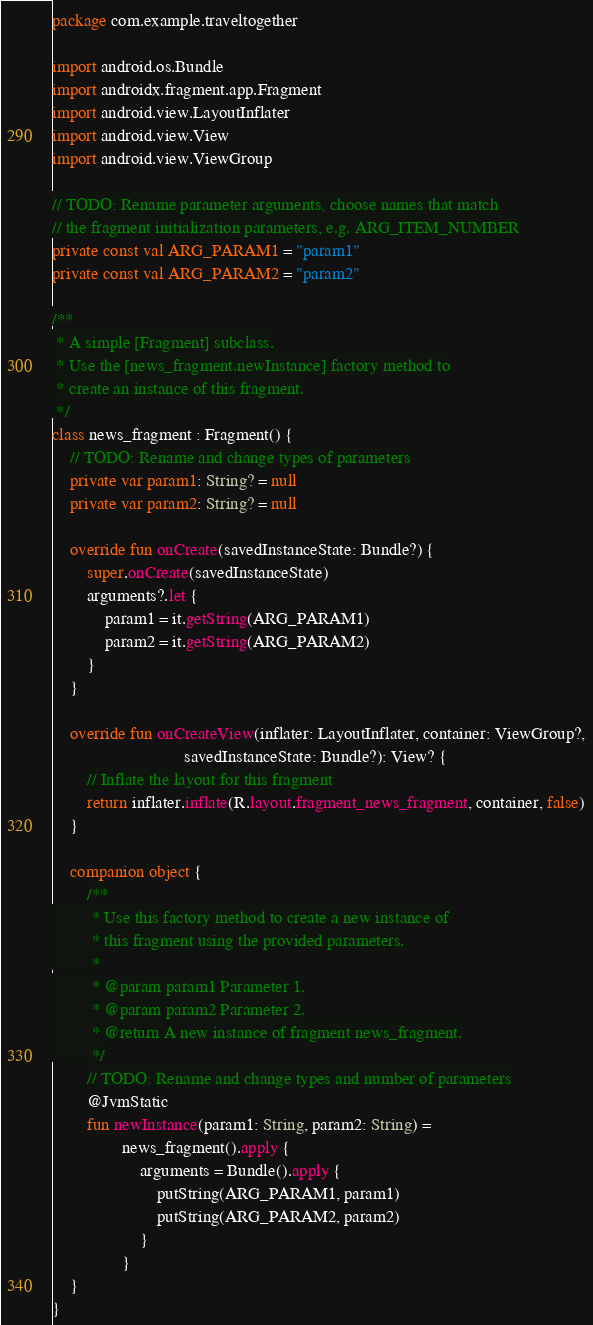Convert code to text. <code><loc_0><loc_0><loc_500><loc_500><_Kotlin_>package com.example.traveltogether

import android.os.Bundle
import androidx.fragment.app.Fragment
import android.view.LayoutInflater
import android.view.View
import android.view.ViewGroup

// TODO: Rename parameter arguments, choose names that match
// the fragment initialization parameters, e.g. ARG_ITEM_NUMBER
private const val ARG_PARAM1 = "param1"
private const val ARG_PARAM2 = "param2"

/**
 * A simple [Fragment] subclass.
 * Use the [news_fragment.newInstance] factory method to
 * create an instance of this fragment.
 */
class news_fragment : Fragment() {
    // TODO: Rename and change types of parameters
    private var param1: String? = null
    private var param2: String? = null

    override fun onCreate(savedInstanceState: Bundle?) {
        super.onCreate(savedInstanceState)
        arguments?.let {
            param1 = it.getString(ARG_PARAM1)
            param2 = it.getString(ARG_PARAM2)
        }
    }

    override fun onCreateView(inflater: LayoutInflater, container: ViewGroup?,
                              savedInstanceState: Bundle?): View? {
        // Inflate the layout for this fragment
        return inflater.inflate(R.layout.fragment_news_fragment, container, false)
    }

    companion object {
        /**
         * Use this factory method to create a new instance of
         * this fragment using the provided parameters.
         *
         * @param param1 Parameter 1.
         * @param param2 Parameter 2.
         * @return A new instance of fragment news_fragment.
         */
        // TODO: Rename and change types and number of parameters
        @JvmStatic
        fun newInstance(param1: String, param2: String) =
                news_fragment().apply {
                    arguments = Bundle().apply {
                        putString(ARG_PARAM1, param1)
                        putString(ARG_PARAM2, param2)
                    }
                }
    }
}</code> 